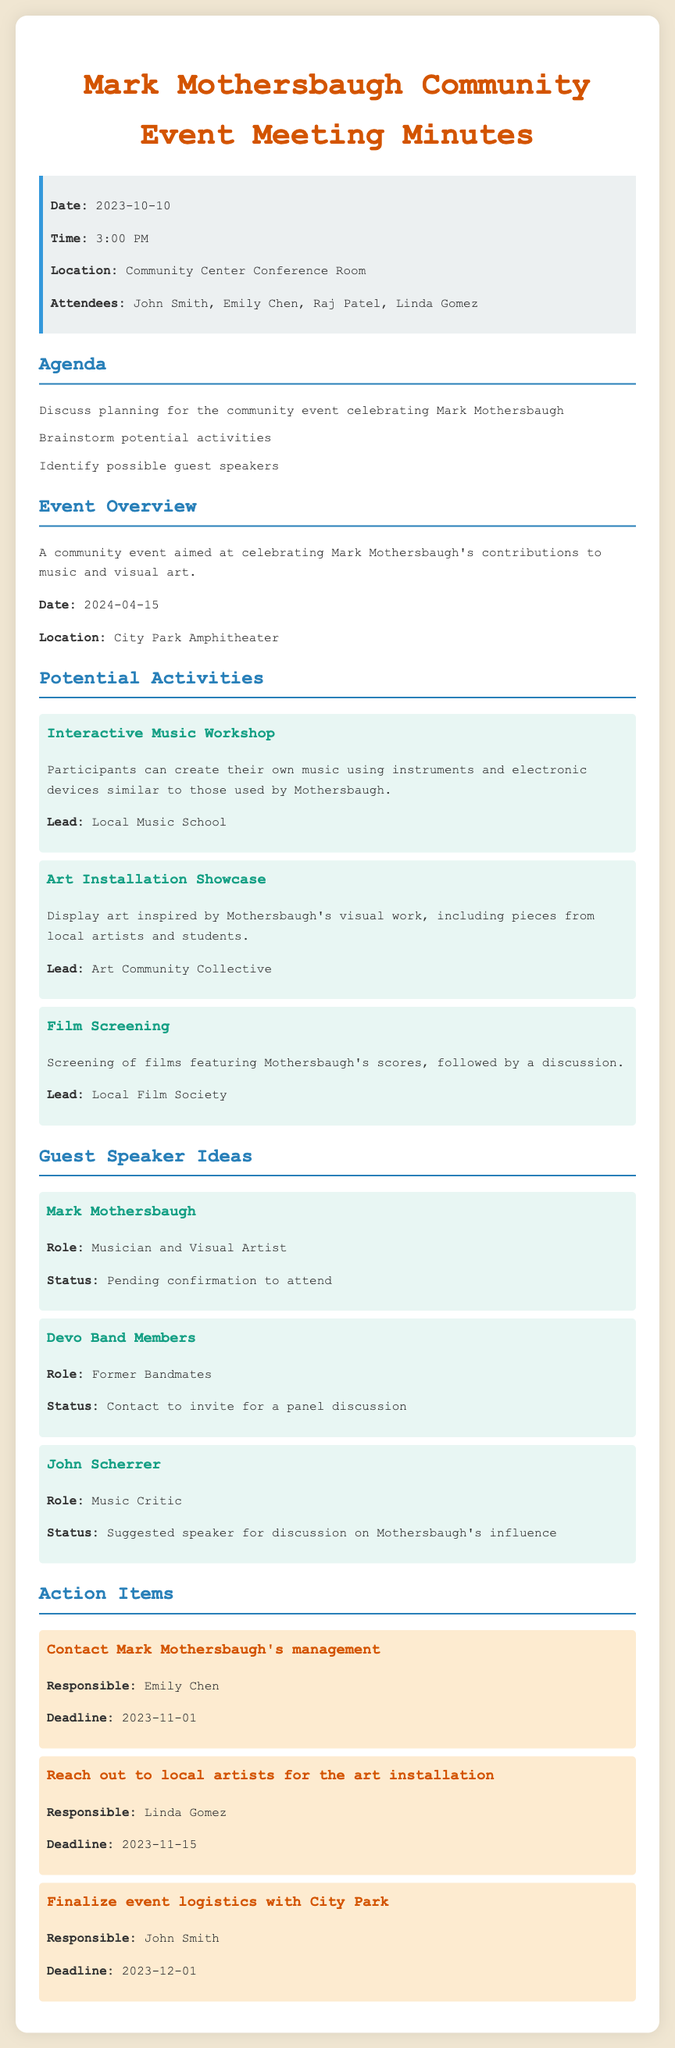what is the date of the meeting? The date of the meeting is explicitly stated in the document.
Answer: 2023-10-10 what is the location of the community event? The location of the community event is provided in the event overview section of the document.
Answer: City Park Amphitheater who is responsible for contacting Mark Mothersbaugh's management? The document specifies who is tasked with this action item.
Answer: Emily Chen what type of workshop is planned for the event? The document mentions the planned activity focusing on music creation.
Answer: Interactive Music Workshop when is the deadline to reach out to local artists for the art installation? The deadline for this action item is clearly indicated in the document.
Answer: 2023-11-15 who proposed John Scherrer as a speaker? The document suggests John Scherrer as a speaker for discussing influences, but it does not specify who proposed him.
Answer: Not mentioned how many attendees were present at the meeting? The document lists the attendees in the info box section.
Answer: 4 what are the possible guest speakers mentioned? This question asks for a summary of who could be guest speakers based on the document.
Answer: Mark Mothersbaugh, Devo Band Members, John Scherrer what is the status of Mark Mothersbaugh's attendance? The document provides the current status regarding his participation in the event.
Answer: Pending confirmation to attend 